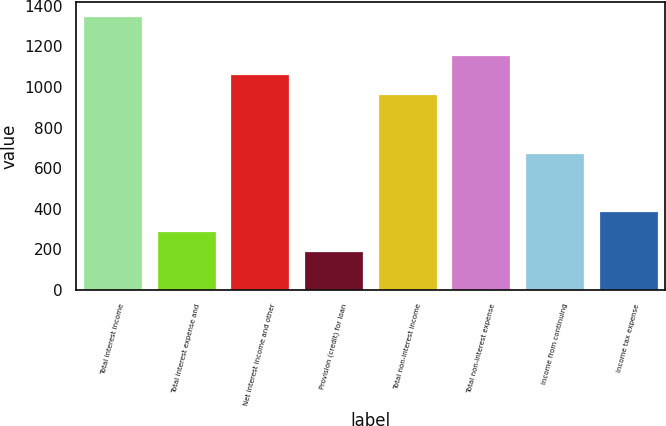Convert chart. <chart><loc_0><loc_0><loc_500><loc_500><bar_chart><fcel>Total interest income<fcel>Total interest expense and<fcel>Net interest income and other<fcel>Provision (credit) for loan<fcel>Total non-interest income<fcel>Total non-interest expense<fcel>Income from continuing<fcel>Income tax expense<nl><fcel>1352.35<fcel>289.97<fcel>1062.61<fcel>193.39<fcel>966.03<fcel>1159.19<fcel>676.29<fcel>386.55<nl></chart> 